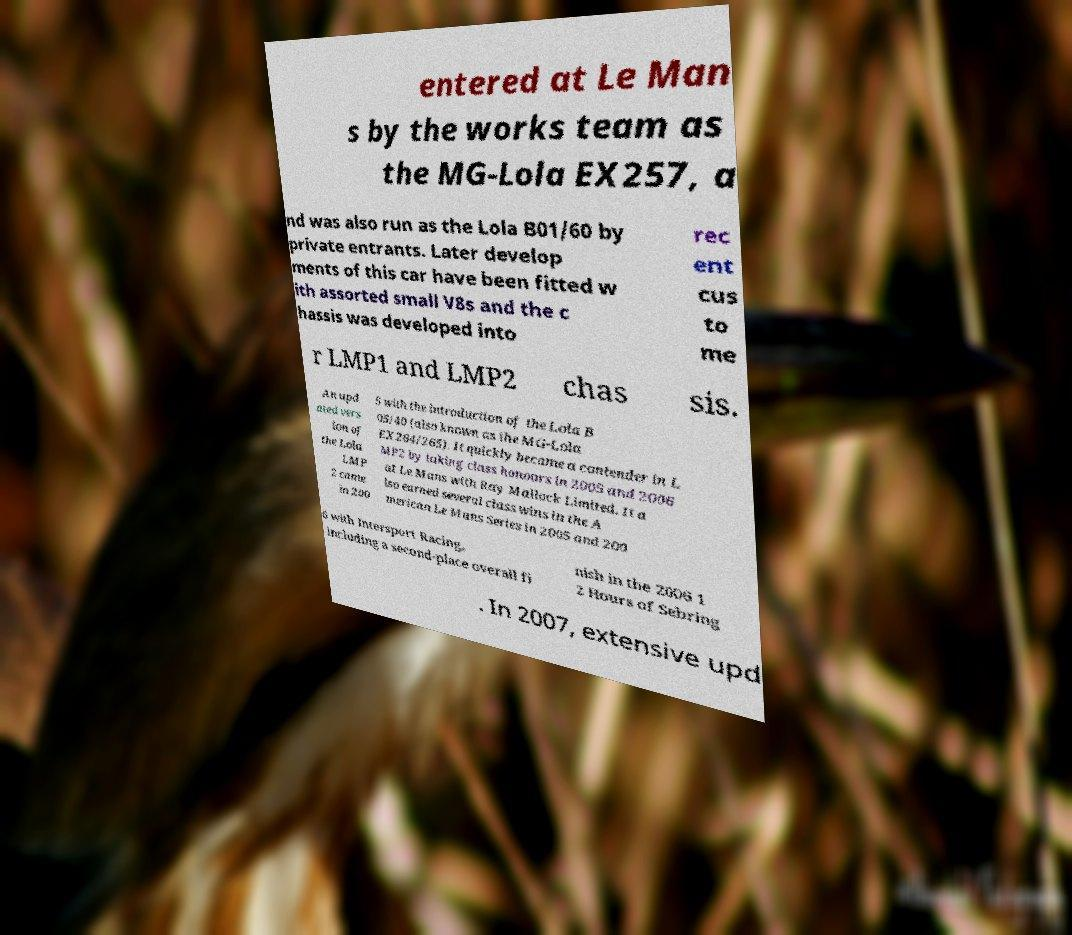Please read and relay the text visible in this image. What does it say? entered at Le Man s by the works team as the MG-Lola EX257, a nd was also run as the Lola B01/60 by private entrants. Later develop ments of this car have been fitted w ith assorted small V8s and the c hassis was developed into rec ent cus to me r LMP1 and LMP2 chas sis. An upd ated vers ion of the Lola LMP 2 came in 200 5 with the introduction of the Lola B 05/40 (also known as the MG-Lola EX264/265). It quickly became a contender in L MP2 by taking class honours in 2005 and 2006 at Le Mans with Ray Mallock Limited. It a lso earned several class wins in the A merican Le Mans Series in 2005 and 200 6 with Intersport Racing, including a second-place overall fi nish in the 2006 1 2 Hours of Sebring . In 2007, extensive upd 